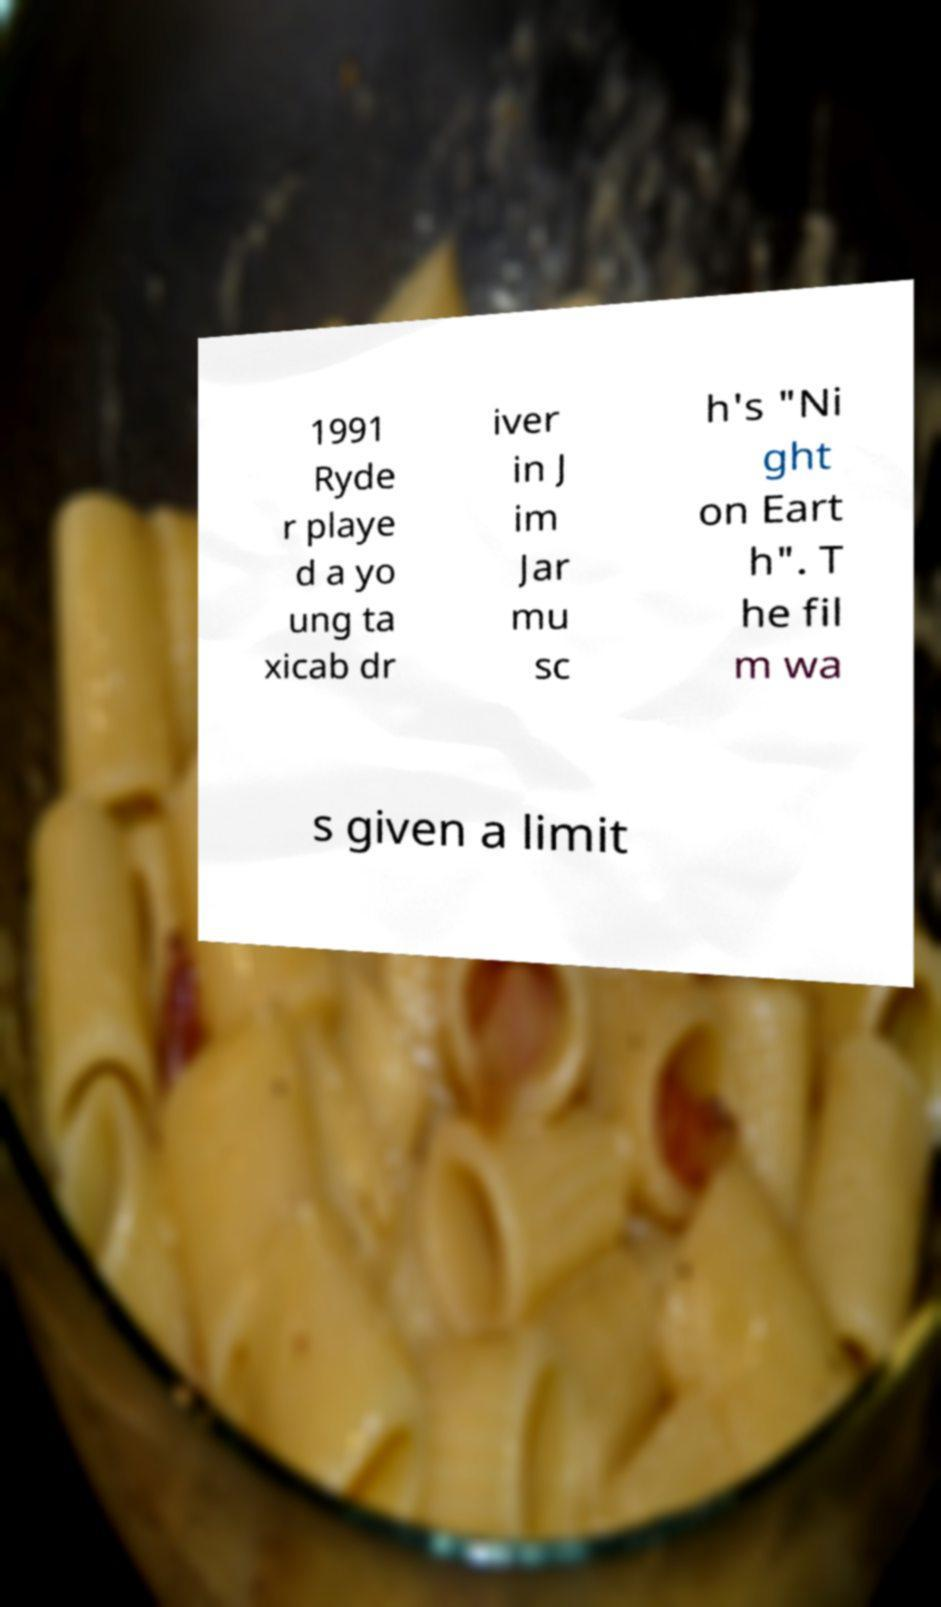Can you read and provide the text displayed in the image?This photo seems to have some interesting text. Can you extract and type it out for me? 1991 Ryde r playe d a yo ung ta xicab dr iver in J im Jar mu sc h's "Ni ght on Eart h". T he fil m wa s given a limit 